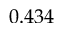Convert formula to latex. <formula><loc_0><loc_0><loc_500><loc_500>0 . 4 3 4</formula> 